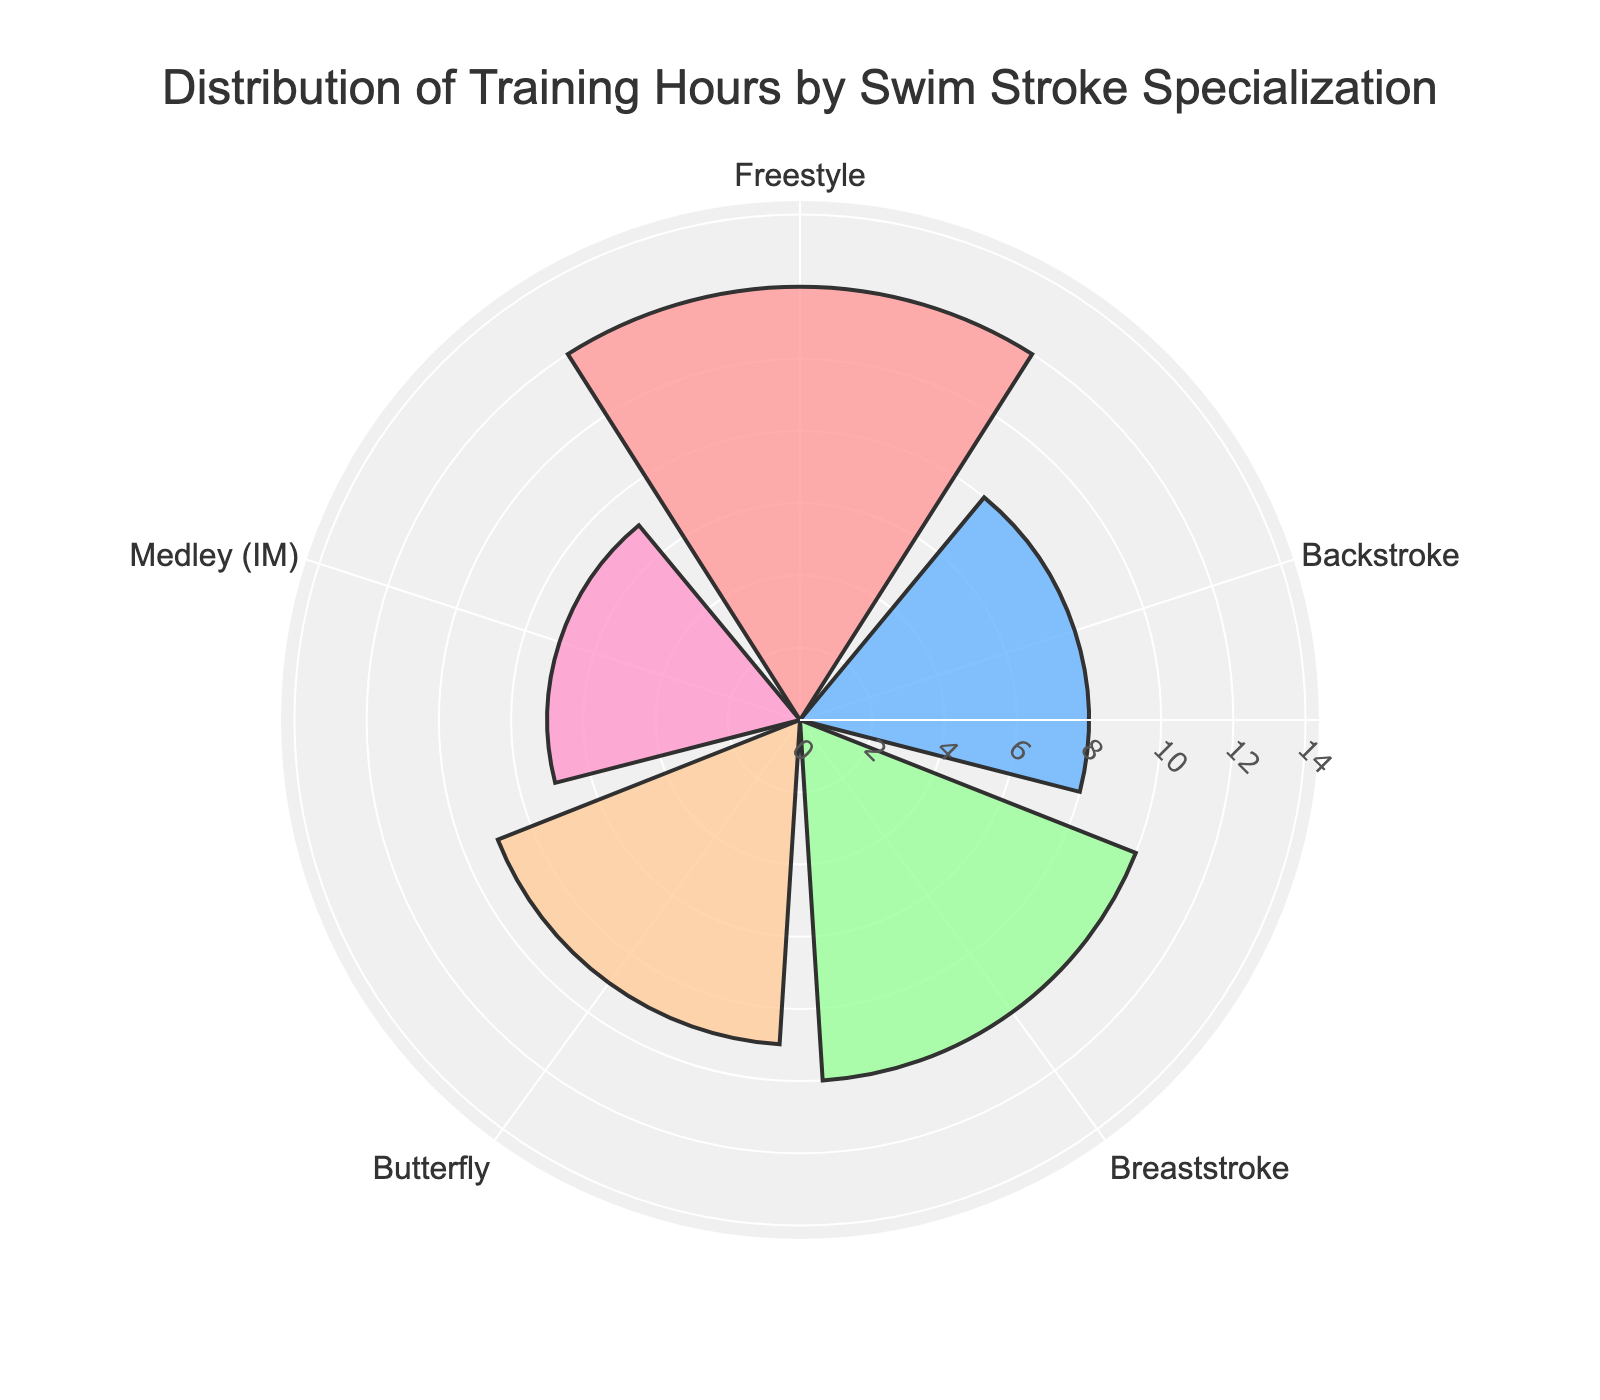What is the title of the polar area chart? The title is usually displayed at the top of the chart in a larger font, making it straightforward to identify. In this chart, it is displayed prominently.
Answer: Distribution of Training Hours by Swim Stroke Specialization What are the training hours for the Breaststroke? By looking at the segment labeled "Breaststroke", we can see the length extending from the center, which represents the training hours.
Answer: 10 Which stroke has the least training hours? By comparing the lengths of all segments, the shortest one corresponds to the Medley.
Answer: Medley (IM) How many more training hours does Freestyle have compared to Medley (IM)? Freestyle has 12 training hours and Medley (IM) has 7. The difference is calculated as 12 - 7.
Answer: 5 What is the total number of training hours spent across all swim strokes? Summing up the training hours for all strokes: 12 (Freestyle) + 8 (Backstroke) + 10 (Breaststroke) + 9 (Butterfly) + 7 (Medley (IM)) = 46.
Answer: 46 What is the average training hours per stroke? The total training hours are 46, and there are 5 strokes. The average is calculated by 46 / 5.
Answer: 9.2 Which stroke has the second highest training hours? By comparing the lengths of the segments, the second longest segment belongs to the Breaststroke.
Answer: Breaststroke Are the training hours for Butterfly greater than or equal to those of Backstroke? Comparing the segments, Butterfly has 9 training hours and Backstroke has 8. Since 9 is greater than 8, the answer is yes.
Answer: Yes What color is used to represent the Backstroke segment? By observing the chart, the segment representing Backstroke can be identified by its distinct color which in this case is blue.
Answer: Blue In the chart, which swim stroke specialization is located next to Butterfly in the clockwise direction? Following around the polar chart in a clockwise direction from the Butterfly segment, the next segment is Medley (IM).
Answer: Medley (IM) 